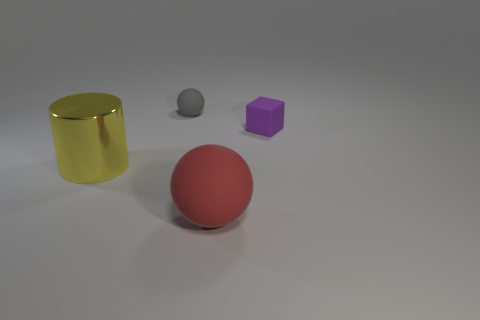Add 1 red balls. How many objects exist? 5 Subtract all blocks. How many objects are left? 3 Subtract all tiny spheres. Subtract all tiny balls. How many objects are left? 2 Add 4 big yellow things. How many big yellow things are left? 5 Add 4 tiny yellow matte balls. How many tiny yellow matte balls exist? 4 Subtract 0 brown cubes. How many objects are left? 4 